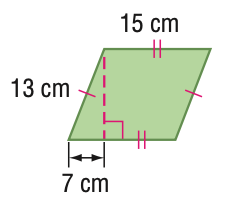Question: Find the perimeter of the figure. Round to the nearest tenth if necessary.
Choices:
A. 28
B. 56
C. 112
D. 164
Answer with the letter. Answer: B Question: Find the area of the figure. Round to the nearest tenth if necessary.
Choices:
A. 56
B. 82.2
C. 164.3
D. 328.6
Answer with the letter. Answer: C 